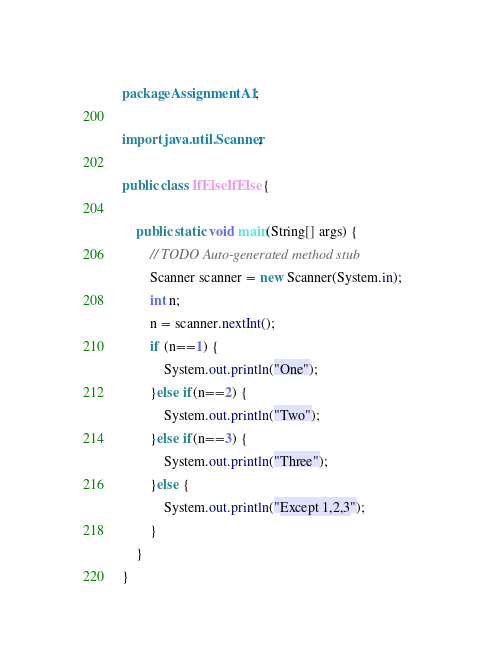Convert code to text. <code><loc_0><loc_0><loc_500><loc_500><_Java_>package AssignmentA1;

import java.util.Scanner;

public class IfElseIfElse {

	public static void main(String[] args) {
		// TODO Auto-generated method stub
		Scanner scanner = new Scanner(System.in);
		int n;
		n = scanner.nextInt();
		if (n==1) {
			System.out.println("One");
		}else if(n==2) {
			System.out.println("Two");
		}else if(n==3) {
			System.out.println("Three");
		}else {
			System.out.println("Except 1,2,3");
		}
	}
}
</code> 